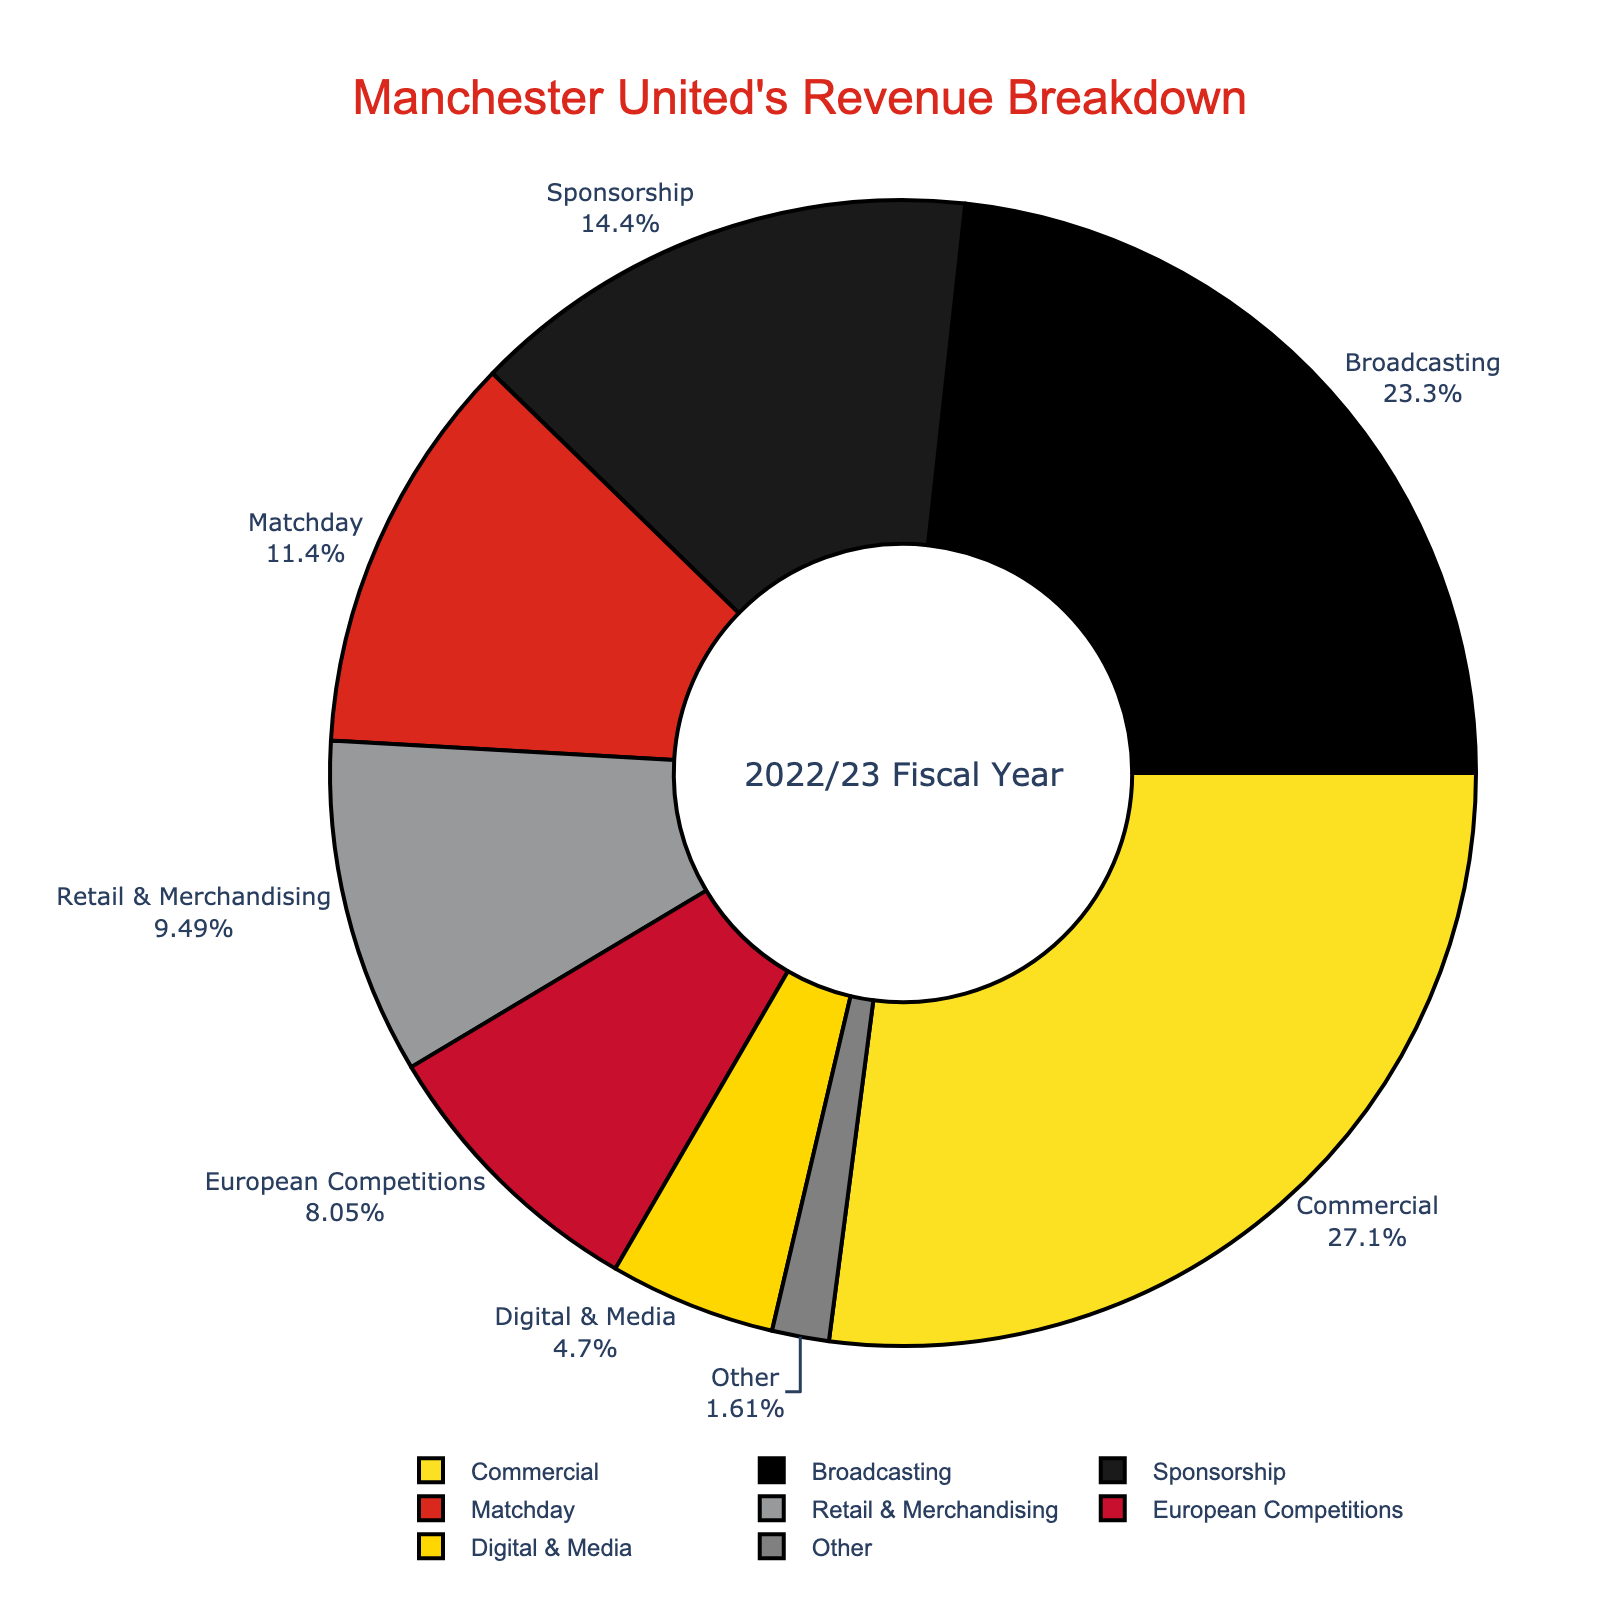Which revenue source contributes the most to Manchester United's total revenue? By looking at the pie chart, the commercial section is the largest slice of the pie.
Answer: Commercial What percentage of the total revenue comes from broadcasting? The pie chart shows labels with percentages; the broadcasting slice is labeled with the percentage value.
Answer: 24.1% How much more revenue does Manchester United get from matchday compared to digital & media? The pie chart shows the revenue values for each source. Matchday generates £110.5 million and digital & media generates £45.6 million. The difference is calculated as £110.5 million - £45.6 million.
Answer: £64.9 million Is the revenue from retail & merchandising greater or less than half of the revenue from commercial activities? Revenue from retail & merchandising is £92.1 million, and half of the revenue from commercial is £262.8 million / 2 = £131.4 million. Since £92.1 million is less than £131.4 million, the answer is less.
Answer: Less What's the combined revenue from European competitions and other sources? Revenue from European competitions is £78.2 million and from other sources is £15.6 million. Their combined revenue is £78.2 million + £15.6 million.
Answer: £93.8 million Which slice of the pie chart appears smallest? The pie chart visually shows that the "Other" category is the smallest slice.
Answer: Other What percentage of revenue comes from sponsorship compared to the total? The pie chart shows that the sponsorship percentage is labeled. By inspecting the slice, this value is found.
Answer: 15% How does the retail & merchandising revenue compare to the total broadcasting revenue? Retail & merchandising revenue is £92.1 million and broadcasting revenue is £225.9 million. By comparing these two values, it is clear broadcasting is higher.
Answer: Less What is the most dominant color in the pie chart? By observing the pie chart, the color associated with the largest segment (Commercial) is visually the most dominant color.
Answer: Yellow What is the total revenue from digital & media and sponsorship combined? Revenue from digital & media is £45.6 million and from sponsorship is £140.3 million. Their total is calculated by adding these two values together.
Answer: £185.9 million 